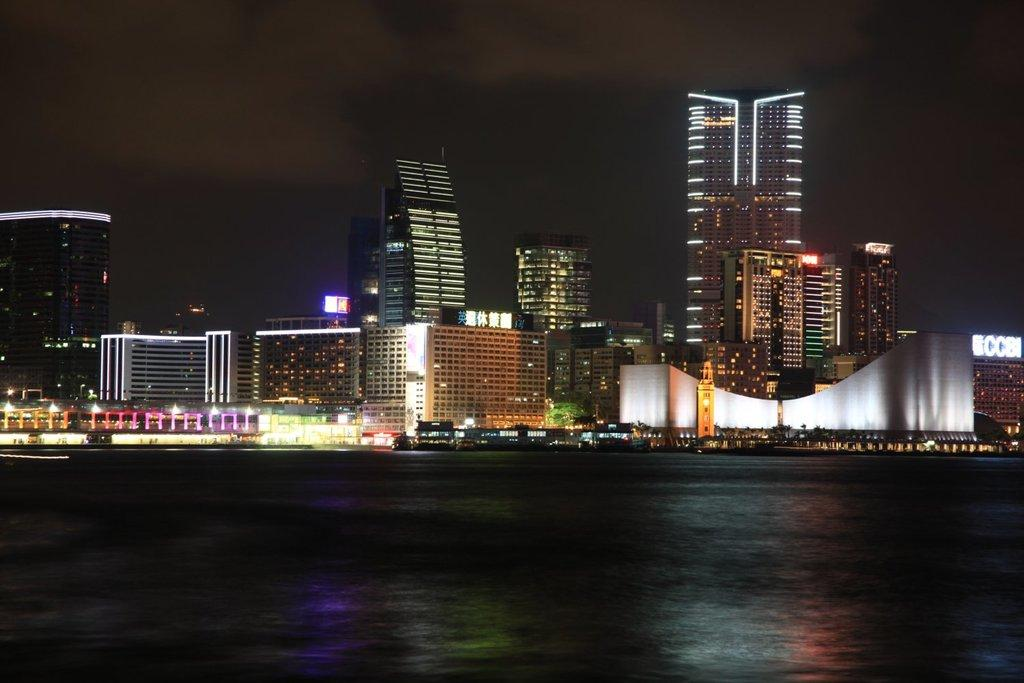What type of buildings can be seen in the background of the image? There are skyscrapers in the background of the image. What feature of the skyscrapers is noticeable? The skyscrapers have many lights. What is located in the foreground of the image? There is a lake in the foreground of the image. What part of the natural environment is visible in the image? The sky is visible in the image. What can be observed in the sky? Clouds are present in the sky. What type of hose can be seen spraying water into the lake in the image? There is no hose present in the image; it features skyscrapers, a lake, and clouds in the sky. What type of air is depicted in the image? The image does not depict a specific type of air; it simply shows clouds in the sky. 